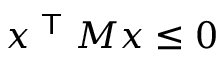Convert formula to latex. <formula><loc_0><loc_0><loc_500><loc_500>x ^ { T } M x \leq 0</formula> 